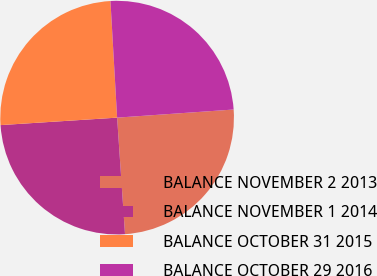Convert chart. <chart><loc_0><loc_0><loc_500><loc_500><pie_chart><fcel>BALANCE NOVEMBER 2 2013<fcel>BALANCE NOVEMBER 1 2014<fcel>BALANCE OCTOBER 31 2015<fcel>BALANCE OCTOBER 29 2016<nl><fcel>25.03%<fcel>25.06%<fcel>25.11%<fcel>24.8%<nl></chart> 